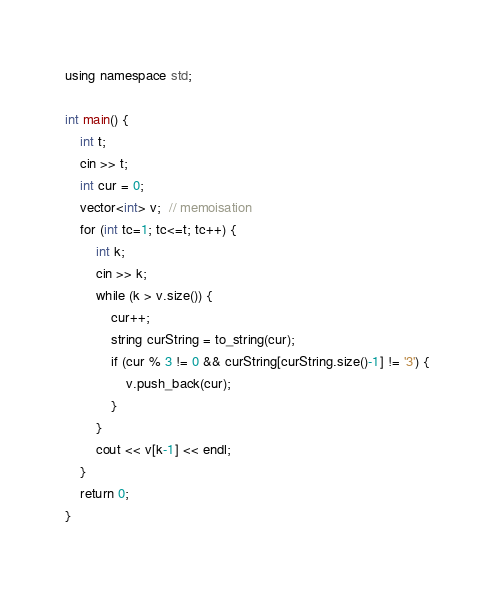Convert code to text. <code><loc_0><loc_0><loc_500><loc_500><_C++_>using namespace std;

int main() {
    int t;
    cin >> t;
    int cur = 0;
    vector<int> v;  // memoisation
    for (int tc=1; tc<=t; tc++) {
        int k;
        cin >> k;
        while (k > v.size()) {
            cur++;
            string curString = to_string(cur);
            if (cur % 3 != 0 && curString[curString.size()-1] != '3') {
                v.push_back(cur);
            }
        }
        cout << v[k-1] << endl;
    }
    return 0;
}
</code> 